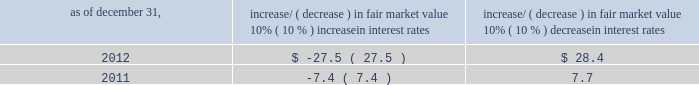Item 7a .
Quantitative and qualitative disclosures about market risk ( amounts in millions ) in the normal course of business , we are exposed to market risks related to interest rates , foreign currency rates and certain balance sheet items .
From time to time , we use derivative instruments , pursuant to established guidelines and policies , to manage some portion of these risks .
Derivative instruments utilized in our hedging activities are viewed as risk management tools and are not used for trading or speculative purposes .
Interest rates our exposure to market risk for changes in interest rates relates primarily to the fair market value and cash flows of our debt obligations .
The majority of our debt ( approximately 93% ( 93 % ) and 91% ( 91 % ) as of december 31 , 2012 and 2011 , respectively ) bears interest at fixed rates .
We do have debt with variable interest rates , but a 10% ( 10 % ) increase or decrease in interest rates would not be material to our interest expense or cash flows .
The fair market value of our debt is sensitive to changes in interest rates , and the impact of a 10% ( 10 % ) change in interest rates is summarized below .
Increase/ ( decrease ) in fair market value as of december 31 , 10% ( 10 % ) increase in interest rates 10% ( 10 % ) decrease in interest rates .
We have used interest rate swaps for risk management purposes to manage our exposure to changes in interest rates .
During 2012 , we entered into and exited forward-starting interest rate swap agreements to effectively lock in the benchmark rate related to our 3.75% ( 3.75 % ) senior notes due 2023 , which we issued in november 2012 .
We do not have any interest rate swaps outstanding as of december 31 , 2012 .
We had $ 2590.8 of cash , cash equivalents and marketable securities as of december 31 , 2012 that we generally invest in conservative , short-term investment-grade securities .
The interest income generated from these investments is subject to both domestic and foreign interest rate movements .
During 2012 and 2011 , we had interest income of $ 29.5 and $ 37.8 , respectively .
Based on our 2012 results , a 100 basis point increase or decrease in interest rates would affect our interest income by approximately $ 26.0 , assuming that all cash , cash equivalents and marketable securities are impacted in the same manner and balances remain constant from year-end 2012 levels .
Foreign currency rates we are subject to translation and transaction risks related to changes in foreign currency exchange rates .
Since we report revenues and expenses in u.s .
Dollars , changes in exchange rates may either positively or negatively affect our consolidated revenues and expenses ( as expressed in u.s .
Dollars ) from foreign operations .
The primary foreign currencies that impacted our results during 2012 were the brazilian real , euro , indian rupee and the south african rand .
Based on 2012 exchange rates and operating results , if the u.s .
Dollar were to strengthen or weaken by 10% ( 10 % ) , we currently estimate operating income would decrease or increase between 3% ( 3 % ) and 5% ( 5 % ) , assuming that all currencies are impacted in the same manner and our international revenue and expenses remain constant at 2012 levels .
The functional currency of our foreign operations is generally their respective local currency .
Assets and liabilities are translated at the exchange rates in effect at the balance sheet date , and revenues and expenses are translated at the average exchange rates during the period presented .
The resulting translation adjustments are recorded as a component of accumulated other comprehensive loss , net of tax , in the stockholders 2019 equity section of our consolidated balance sheets .
Our foreign subsidiaries generally collect revenues and pay expenses in their functional currency , mitigating transaction risk .
However , certain subsidiaries may enter into transactions in currencies other than their functional currency .
Assets and liabilities denominated in currencies other than the functional currency are susceptible to movements in foreign currency until final settlement .
Currency transaction gains or losses primarily arising from transactions in currencies other than the functional currency are included in office and general expenses .
We have not entered into a material amount of foreign currency forward exchange contracts or other derivative financial instruments to hedge the effects of potential adverse fluctuations in foreign currency exchange rates. .
What was the ratio of the 10% ( 10 % ) increase/ ( decrease ) in interest rates to the in fair market value as of december 312012? 
Computations: (28.4 / -27.5)
Answer: -1.03273. 